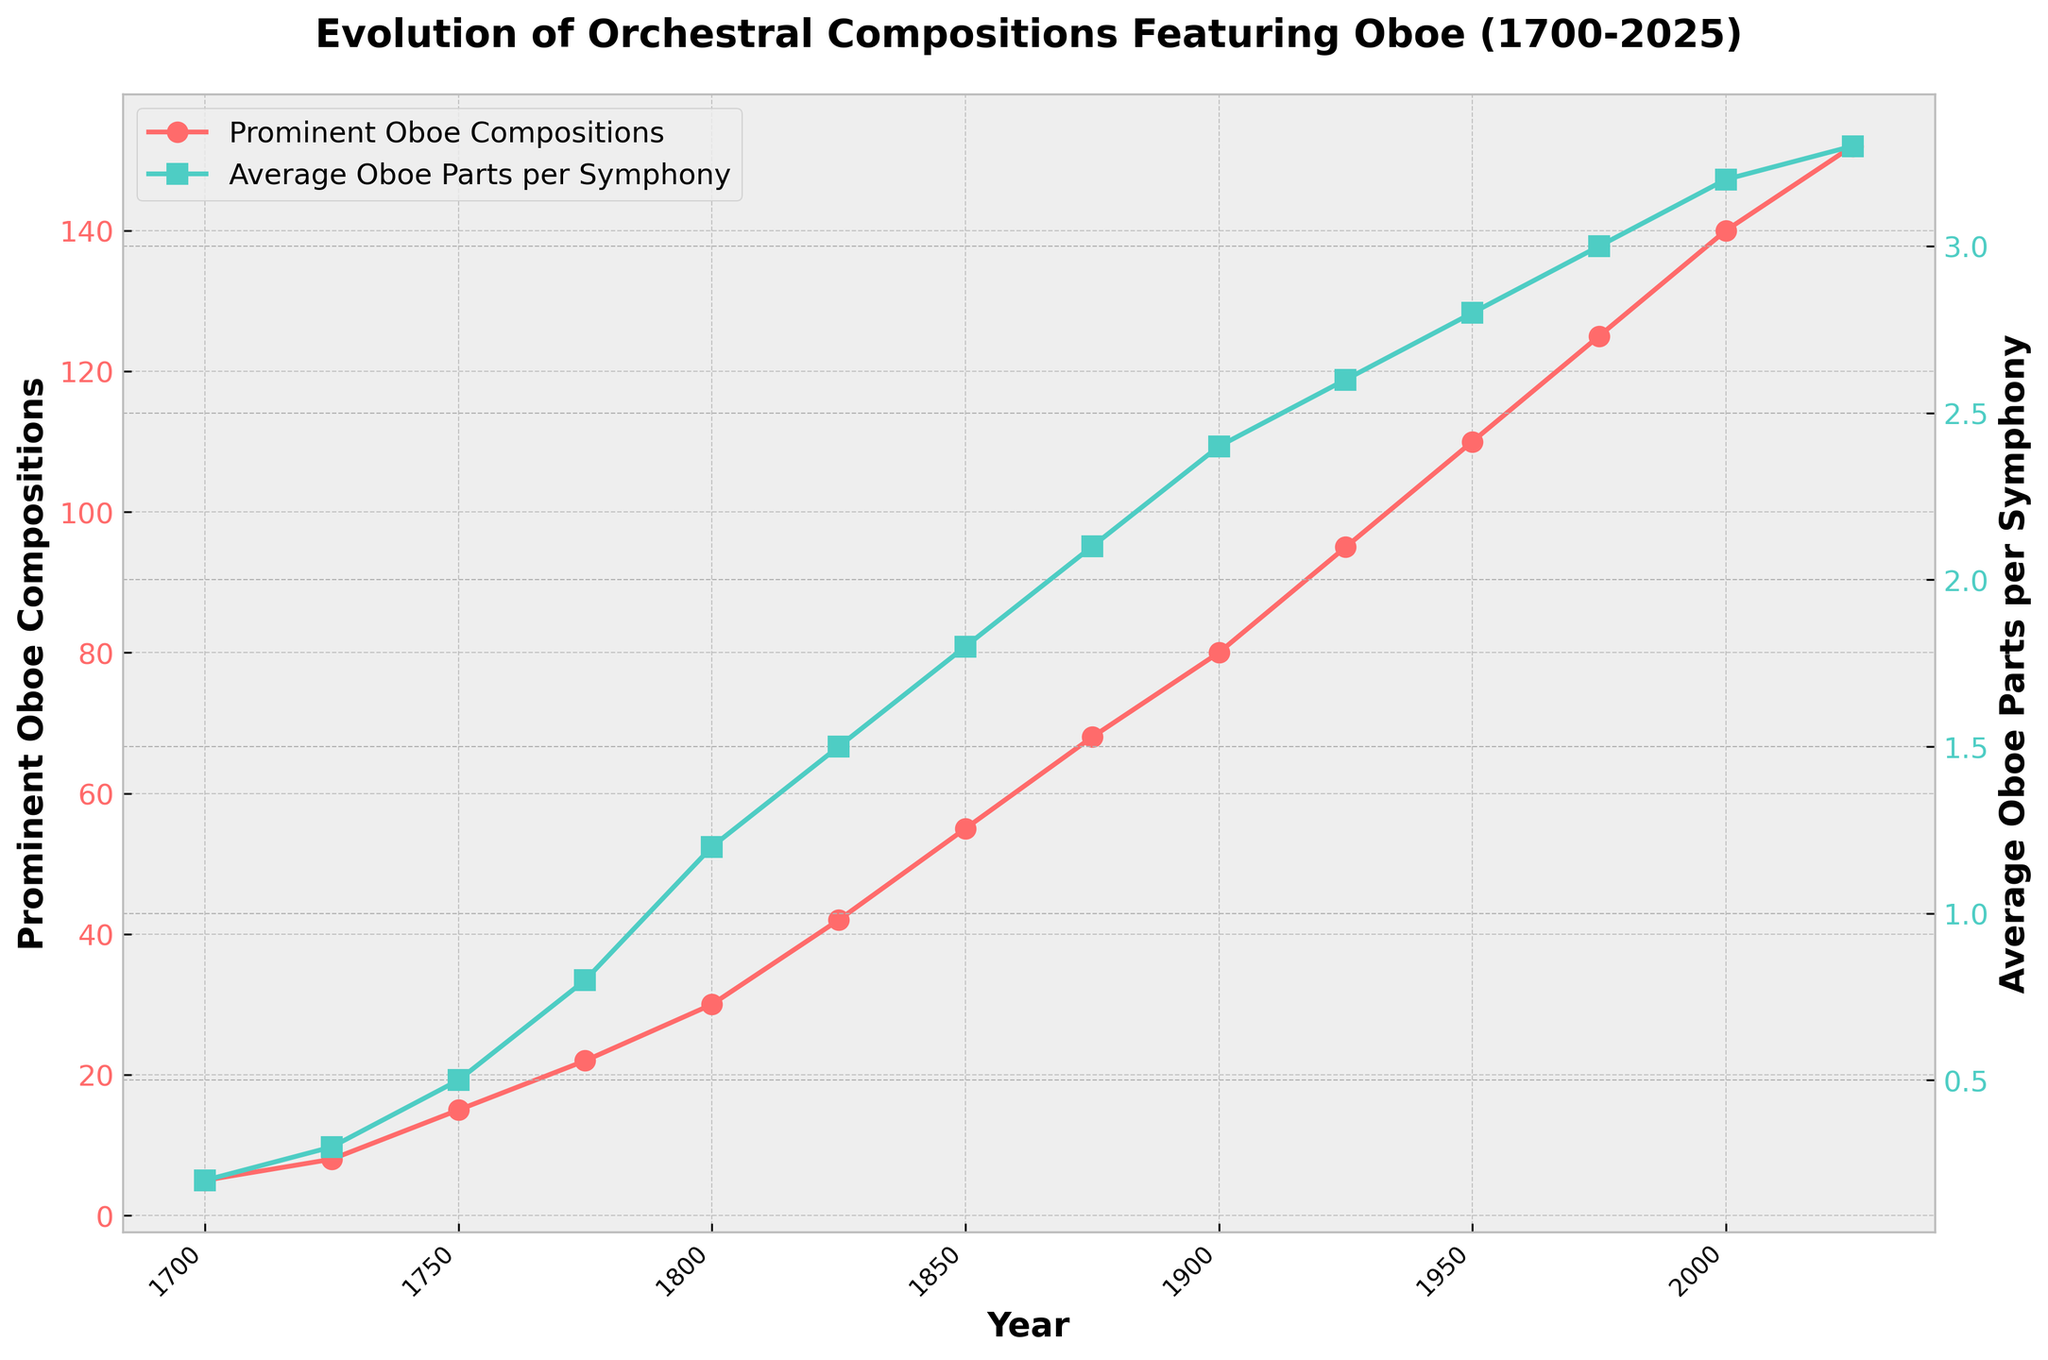How does the number of prominent oboe compositions in 1925 compare to that in 1900? The figure shows that there are 80 prominent oboe compositions in 1900 and 95 in 1925. Comparing these values, we see that 95 > 80.
Answer: 95 is greater than 80 What is the general trend of the average oboe parts per symphony from 1700 to 2025? Observing the green line representing 'Average Oboe Parts per Symphony', we notice that it steadily increases from around 0.2 in 1700 to 3.3 in 2025. Thus, the trend is increasing.
Answer: Increasing How much did the number of prominent oboe compositions increase from 1850 to 1900? In 1850, the number of prominent oboe compositions is 55, and in 1900, it is 80. The increase is calculated by 80 - 55.
Answer: 25 In which period did the 'Average Oboe Parts per Symphony' see the sharpest increase? Looking at the slope of the green line, the steepest increase appears between 1825 (1.5) and 1875 (2.1). Calculating the difference gives 2.1 - 1.5.
Answer: 1825 to 1875 What color represents the 'Prominent Oboe Compositions' line in the plot? The 'Prominent Oboe Compositions' line is represented by a red color in the plot.
Answer: Red How many prominent oboe compositions were there in 1750, and what was the average number of oboe parts per symphony at the same time? The plot shows that in 1750, there were 15 prominent oboe compositions, and the average number of oboe parts per symphony was 0.5.
Answer: 15 and 0.5 Which year had the highest number of prominent oboe compositions, and what was that number? From the red line plotting 'Prominent Oboe Compositions', 2025 has the highest number, which is 152.
Answer: 2025 with 152 By how much did the average oboe parts per symphony increase between 2000 and 2025? The average oboe parts per symphony in 2000 was 3.2, and in 2025 it is 3.3. The increase is calculated as 3.3 - 3.2.
Answer: 0.1 Between which consecutive pairs of years did the number of prominent oboe compositions increase by exactly 20? Observing the red line, from 1950 (110) to 1975 (125), the increase is 125 - 110 = 15. There are no consecutive intervals where the increase is exactly 20.
Answer: None 